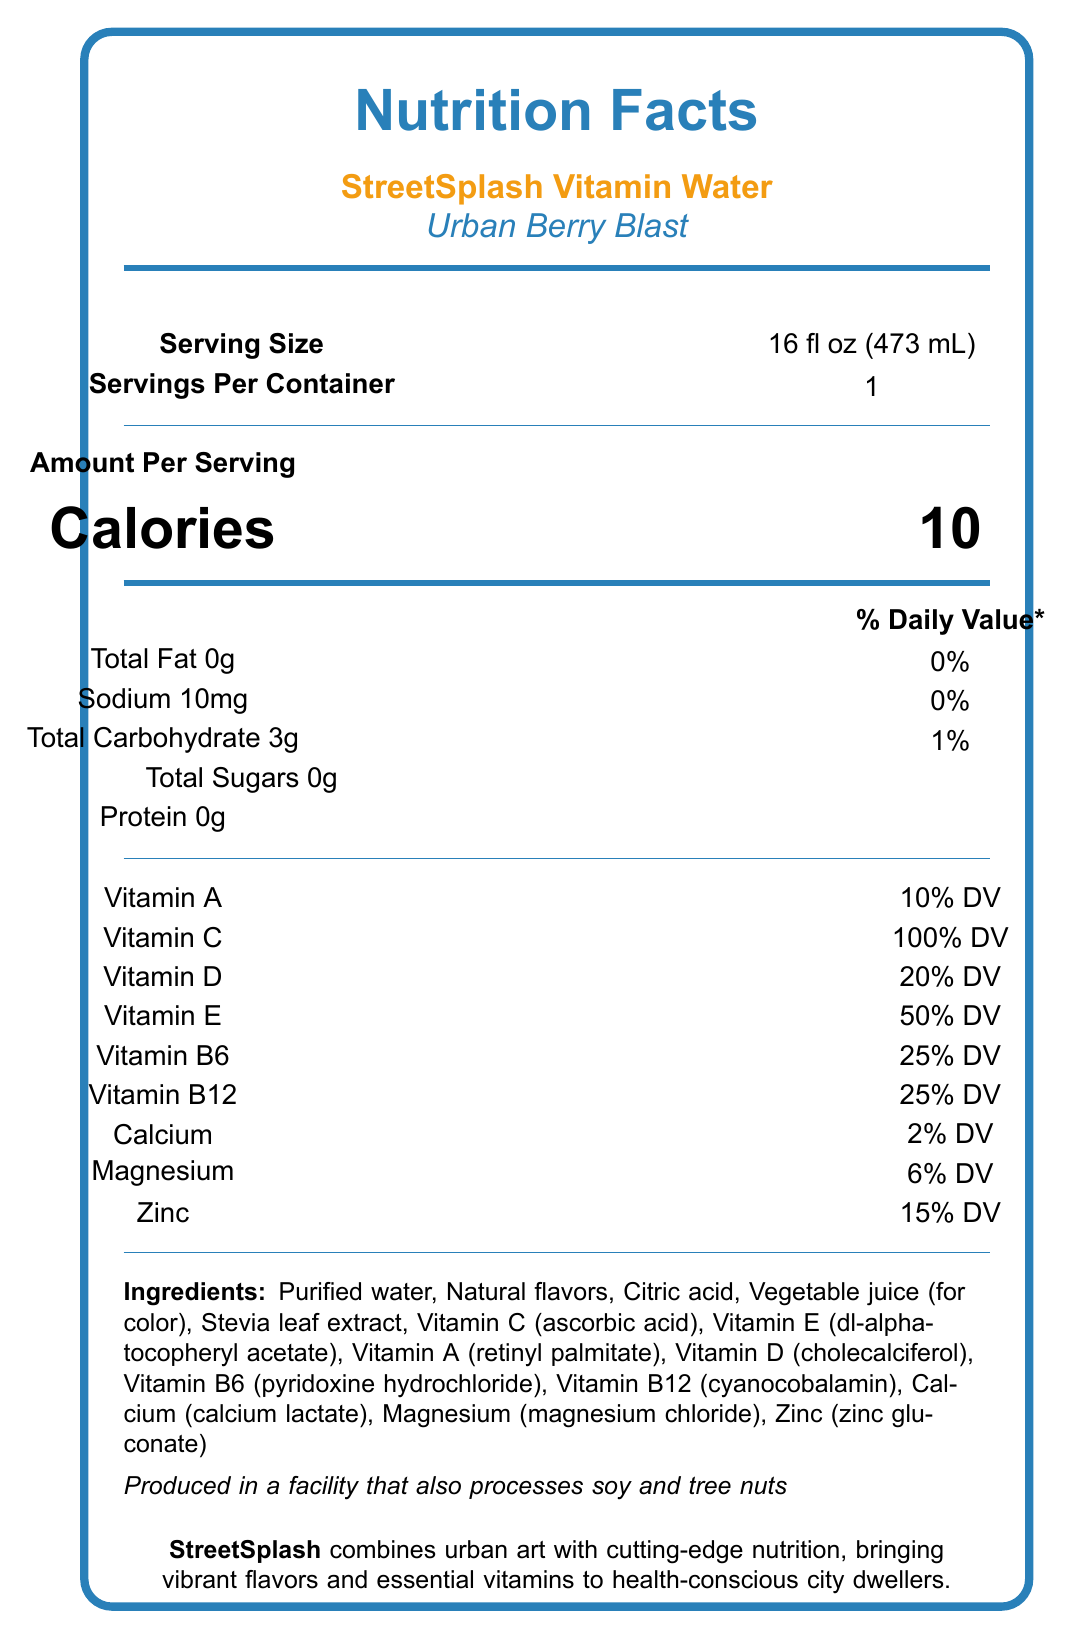what is the serving size of the StreetSplash Vitamin Water? The serving size is clearly indicated near the top of the document under the product name.
Answer: 16 fl oz (473 mL) How much sodium is in each serving? The amount of sodium per serving is listed in the middle section of the document under the nutrient breakdown.
Answer: 10mg What percentage of the daily value of Vitamin C does one serving provide? The provided daily value percentage for Vitamin C is stated in the nutrient section of the document.
Answer: 100% DV What are the main ingredients used in the StreetSplash Vitamin Water? The list of ingredients is detailed in a small section towards the bottom of the document.
Answer: Purified water, Natural flavors, Citric acid, Vegetable juice (for color), Stevia leaf extract, Vitamin C (ascorbic acid), Vitamin E (dl-alpha-tocopheryl acetate), Vitamin A (retinyl palmitate), Vitamin D (cholecalciferol), Vitamin B6 (pyridoxine hydrochloride), Vitamin B12 (cyanocobalamin), Calcium (calcium lactate), Magnesium (magnesium chloride), Zinc (zinc gluconate) What kind of flavors does the Urban Berry Blast have? The document specifies "Natural flavors" as part of the ingredients, which implies the flavor profile.
Answer: Natural flavors Which vitamin has the highest daily value percentage in one serving? 
A. Vitamin A 
B. Vitamin C 
C. Magnesium 
D. Zinc According to the document, Vitamin C offers 100% daily value, which is the highest among the listed vitamins and minerals.
Answer: B. Vitamin C What is the calorie count per serving of StreetSplash Vitamin Water? The calorie count per serving is prominently displayed in the "Amount Per Serving" section.
Answer: 10 calories Is StreetSplash Vitamin Water gluten-free? The document states that the product is gluten-free in the additional information section.
Answer: Yes Which feature is used to describe the bottle design of StreetSplash Vitamin Water? 
i. Street art by Banksy 
ii. Produced in a facility with no allergens 
iii. Made from recycled materials 
iv. Natural flavors used The document mentions that the bottle features graffiti-inspired artwork by renowned street artist Banksy.
Answer: i. Street art by Banksy Does the StreetSplash Vitamin Water contain any artificial colors or sweeteners? The document clearly states that there are no artificial colors or sweeteners in the additional information section.
Answer: No Summarize the main idea of the document. The summary captures the essential details about the product's nutritional content, design, and additional attributes emphasizing its brand's unique merger of street art and health-conscious nutrition.
Answer: StreetSplash Vitamin Water offers a low-calorie, vitamin-enhanced beverage with natural flavors and no artificial colors or sweeteners. Featuring a bold urban-inspired design by Banksy, it contains essential vitamins like Vitamin C, Vitamin D, and various B vitamins, and is gluten-free, vegan, and non-GMO. What is the headquarters address of Urban Oasis Beverages, Inc.? The document does not include the headquarters address; it only provides a mailing address for Urban Oasis Beverages, Inc.
Answer: Not enough information 